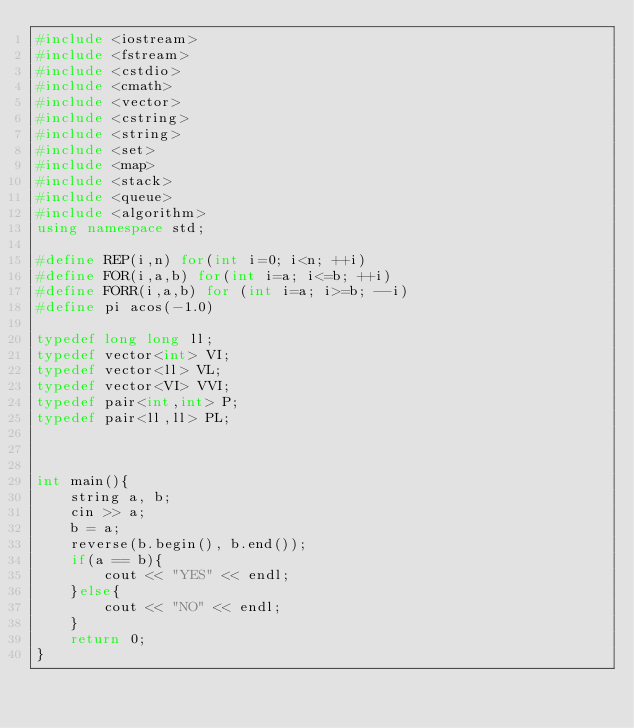<code> <loc_0><loc_0><loc_500><loc_500><_C++_>#include <iostream>
#include <fstream>
#include <cstdio>
#include <cmath>
#include <vector>
#include <cstring>
#include <string>
#include <set>
#include <map>
#include <stack>
#include <queue>
#include <algorithm>
using namespace std;

#define REP(i,n) for(int i=0; i<n; ++i)
#define FOR(i,a,b) for(int i=a; i<=b; ++i)
#define FORR(i,a,b) for (int i=a; i>=b; --i)
#define pi acos(-1.0)

typedef long long ll;
typedef vector<int> VI;
typedef vector<ll> VL;
typedef vector<VI> VVI;
typedef pair<int,int> P;
typedef pair<ll,ll> PL;



int main(){
    string a, b;
    cin >> a;
    b = a;
    reverse(b.begin(), b.end());
    if(a == b){
        cout << "YES" << endl;
    }else{
        cout << "NO" << endl;
    }
    return 0;
}

</code> 